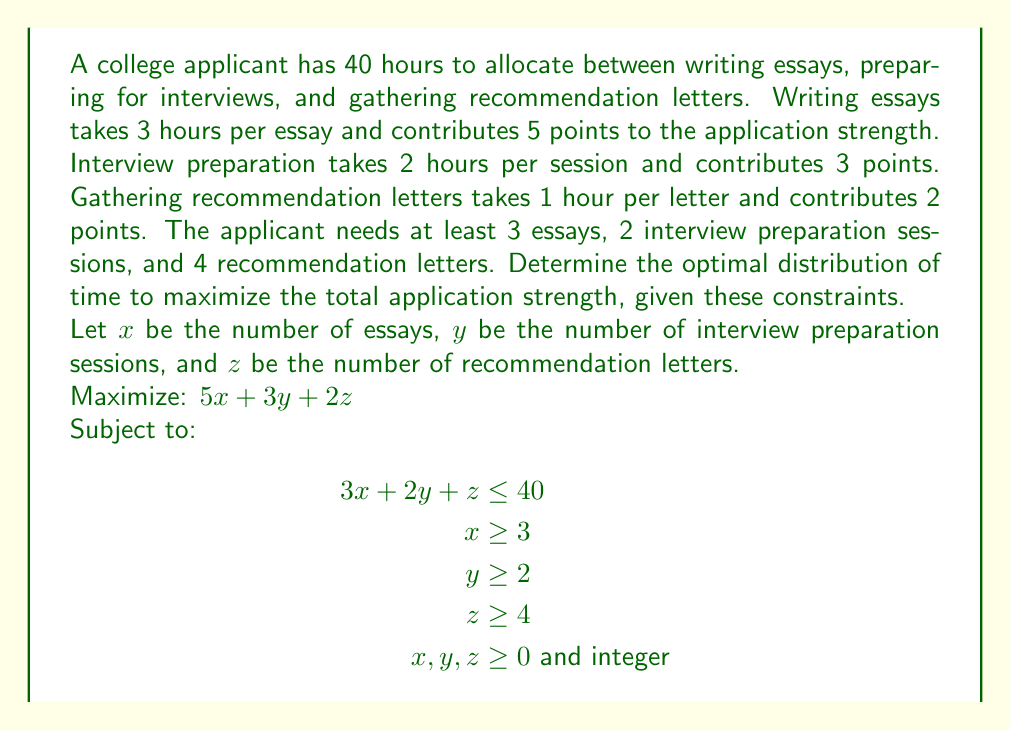Solve this math problem. To solve this linear programming problem, we'll use the simplex method:

1) First, convert inequalities to equations by adding slack variables:
   $$\begin{align}
   3x + 2y + z + s_1 &= 40 \\
   x - s_2 &= 3 \\
   y - s_3 &= 2 \\
   z - s_4 &= 4
   \end{align}$$

2) Set up the initial tableau:
   $$\begin{array}{c|cccccccc|c}
    & x & y & z & s_1 & s_2 & s_3 & s_4 & P & RHS \\
   \hline
   s_1 & 3 & 2 & 1 & 1 & 0 & 0 & 0 & 0 & 40 \\
   s_2 & 1 & 0 & 0 & 0 & -1 & 0 & 0 & 0 & 3 \\
   s_3 & 0 & 1 & 0 & 0 & 0 & -1 & 0 & 0 & 2 \\
   s_4 & 0 & 0 & 1 & 0 & 0 & 0 & -1 & 0 & 4 \\
   \hline
   P & -5 & -3 & -2 & 0 & 0 & 0 & 0 & 1 & 0
   \end{array}$$

3) The most negative entry in the bottom row is -5, corresponding to x. Pivot on the first row.

4) After pivoting:
   $$\begin{array}{c|cccccccc|c}
    & x & y & z & s_1 & s_2 & s_3 & s_4 & P & RHS \\
   \hline
   x & 1 & 2/3 & 1/3 & 1/3 & 0 & 0 & 0 & 0 & 40/3 \\
   s_2 & 0 & -2/3 & -1/3 & -1/3 & -1 & 0 & 0 & 0 & -31/3 \\
   s_3 & 0 & 1 & 0 & 0 & 0 & -1 & 0 & 0 & 2 \\
   s_4 & 0 & 0 & 1 & 0 & 0 & 0 & -1 & 0 & 4 \\
   \hline
   P & 0 & -1 & -1/3 & 5/3 & 0 & 0 & 0 & 1 & 200/3
   \end{array}$$

5) The most negative entry is now -1, corresponding to y. Pivot on the third row.

6) After pivoting:
   $$\begin{array}{c|cccccccc|c}
    & x & y & z & s_1 & s_2 & s_3 & s_4 & P & RHS \\
   \hline
   x & 1 & 0 & 1/3 & 1/3 & 0 & 2/3 & 0 & 0 & 12 \\
   s_2 & 0 & 0 & -1/3 & -1/3 & -1 & -2/3 & 0 & 0 & -11 \\
   y & 0 & 1 & 0 & 0 & 0 & -1 & 0 & 0 & 2 \\
   s_4 & 0 & 0 & 1 & 0 & 0 & 0 & -1 & 0 & 4 \\
   \hline
   P & 0 & 0 & -1/3 & 5/3 & 0 & 1 & 0 & 1 & 68
   \end{array}$$

7) The only negative entry is -1/3, corresponding to z. Pivot on the fourth row.

8) Final tableau:
   $$\begin{array}{c|cccccccc|c}
    & x & y & z & s_1 & s_2 & s_3 & s_4 & P & RHS \\
   \hline
   x & 1 & 0 & 0 & 1/3 & 0 & 2/3 & 1/3 & 0 & 11 \\
   s_2 & 0 & 0 & 0 & -1/3 & -1 & -2/3 & -1/3 & 0 & -12 \\
   y & 0 & 1 & 0 & 0 & 0 & -1 & 0 & 0 & 2 \\
   z & 0 & 0 & 1 & 0 & 0 & 0 & -1 & 0 & 4 \\
   \hline
   P & 0 & 0 & 0 & 5/3 & 0 & 1 & 1/3 & 1 & 69
   \end{array}$$

9) The optimal solution is:
   x = 11 essays
   y = 2 interview preparation sessions
   z = 4 recommendation letters
   Maximum application strength = 69 points

10) Check the constraints:
    3(11) + 2(2) + 4 = 40 hours (exactly meets the time constraint)
    11 ≥ 3, 2 ≥ 2, 4 ≥ 4 (all minimum requirements met)

Therefore, the optimal distribution is 11 essays, 2 interview preparation sessions, and 4 recommendation letters.
Answer: 11 essays, 2 interview prep sessions, 4 recommendation letters; max strength 69 points 